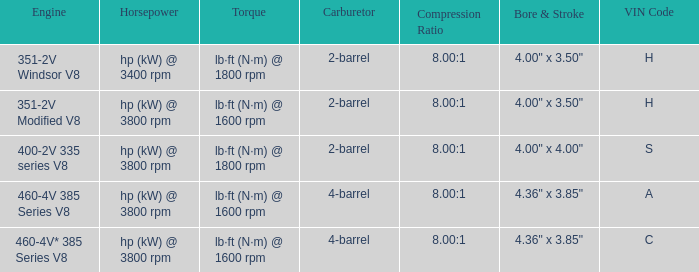What are the bore & stroke specifications for an engine with 4-barrel carburetor and VIN code of A? 4.36" x 3.85". 